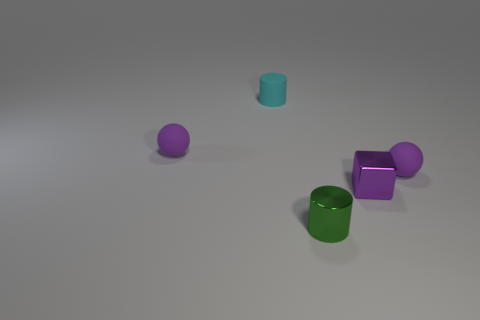Subtract all green cylinders. How many cylinders are left? 1 Subtract all cubes. How many objects are left? 4 Subtract 1 cylinders. How many cylinders are left? 1 Add 1 small purple metal cubes. How many objects exist? 6 Subtract 0 gray cubes. How many objects are left? 5 Subtract all yellow spheres. Subtract all gray cylinders. How many spheres are left? 2 Subtract all purple blocks. How many green cylinders are left? 1 Subtract all purple matte spheres. Subtract all small cylinders. How many objects are left? 1 Add 2 small cyan rubber cylinders. How many small cyan rubber cylinders are left? 3 Add 3 green metal blocks. How many green metal blocks exist? 3 